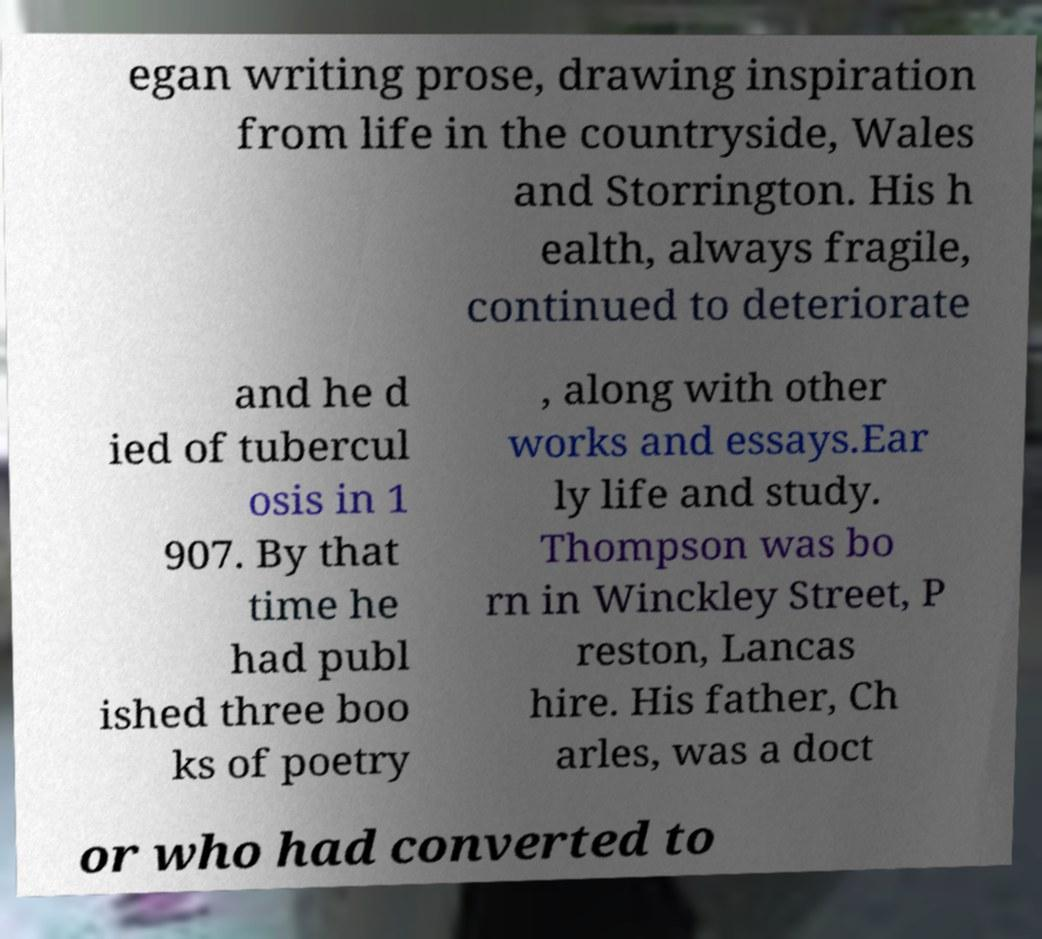For documentation purposes, I need the text within this image transcribed. Could you provide that? egan writing prose, drawing inspiration from life in the countryside, Wales and Storrington. His h ealth, always fragile, continued to deteriorate and he d ied of tubercul osis in 1 907. By that time he had publ ished three boo ks of poetry , along with other works and essays.Ear ly life and study. Thompson was bo rn in Winckley Street, P reston, Lancas hire. His father, Ch arles, was a doct or who had converted to 